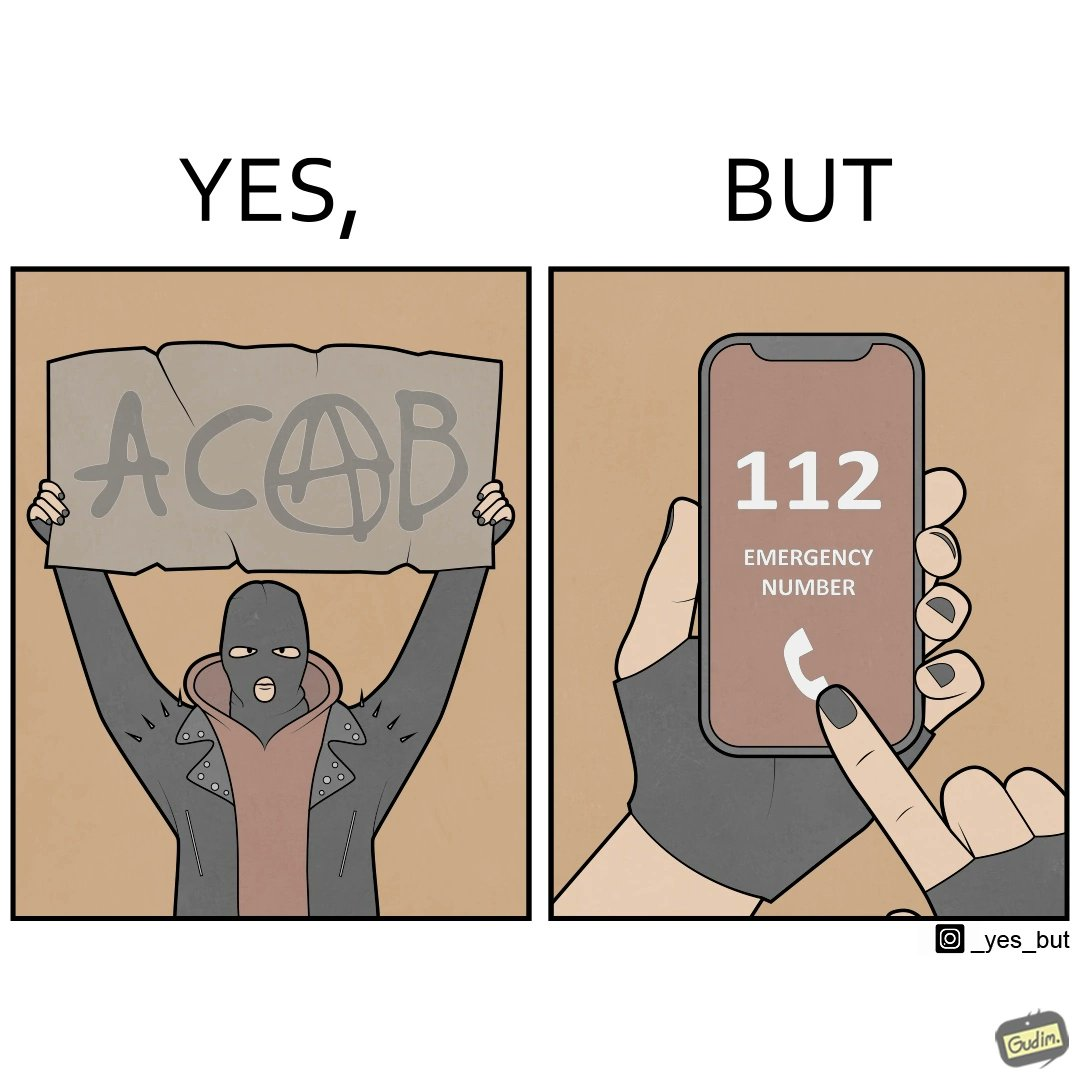Is this a satirical image? Yes, this image is satirical. 